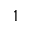Convert formula to latex. <formula><loc_0><loc_0><loc_500><loc_500>1</formula> 